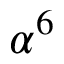<formula> <loc_0><loc_0><loc_500><loc_500>\alpha ^ { 6 }</formula> 